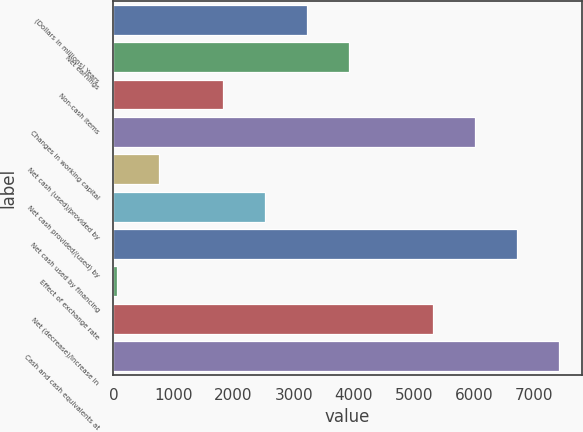<chart> <loc_0><loc_0><loc_500><loc_500><bar_chart><fcel>(Dollars in millions) Years<fcel>Net earnings<fcel>Non-cash items<fcel>Changes in working capital<fcel>Net cash (used)/provided by<fcel>Net cash provided/(used) by<fcel>Net cash used by financing<fcel>Effect of exchange rate<fcel>Net (decrease)/increase in<fcel>Cash and cash equivalents at<nl><fcel>3225.6<fcel>3923.9<fcel>1829<fcel>6018.8<fcel>757.3<fcel>2527.3<fcel>6717.1<fcel>59<fcel>5320.5<fcel>7415.4<nl></chart> 